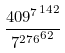<formula> <loc_0><loc_0><loc_500><loc_500>\frac { { 4 0 9 ^ { 7 } } ^ { 1 4 2 } } { { 7 ^ { 2 7 6 } } ^ { 6 2 } }</formula> 